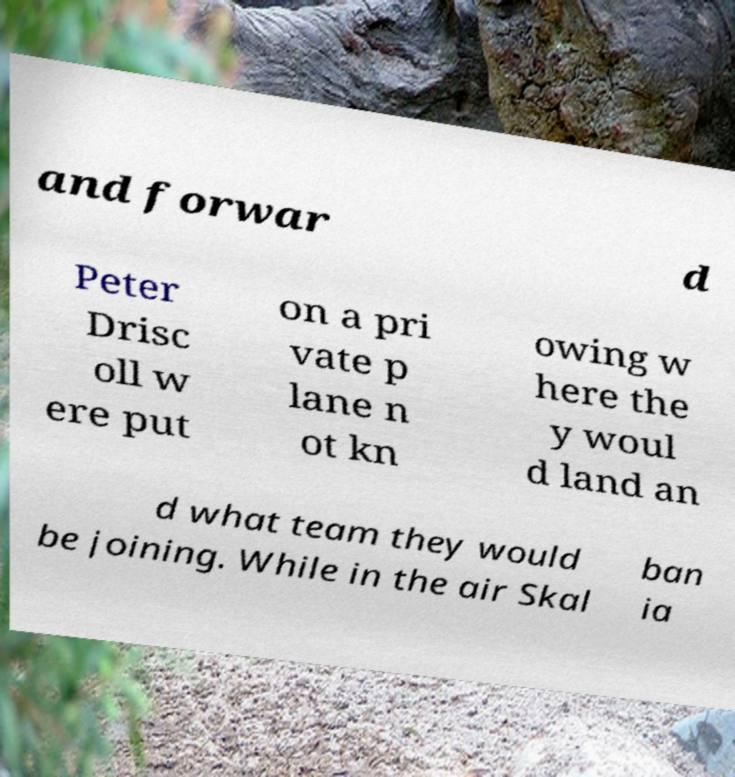What messages or text are displayed in this image? I need them in a readable, typed format. and forwar d Peter Drisc oll w ere put on a pri vate p lane n ot kn owing w here the y woul d land an d what team they would be joining. While in the air Skal ban ia 